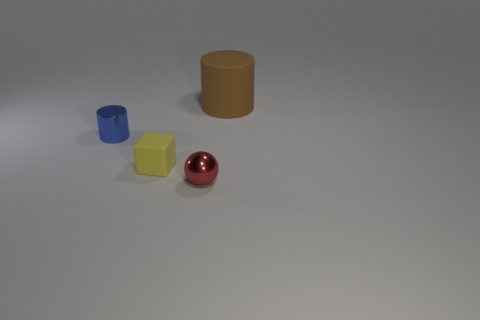Add 3 tiny metallic cylinders. How many objects exist? 7 Subtract all cubes. How many objects are left? 3 Add 2 red metal balls. How many red metal balls are left? 3 Add 4 small brown shiny cubes. How many small brown shiny cubes exist? 4 Subtract 0 gray spheres. How many objects are left? 4 Subtract all small yellow cubes. Subtract all matte cubes. How many objects are left? 2 